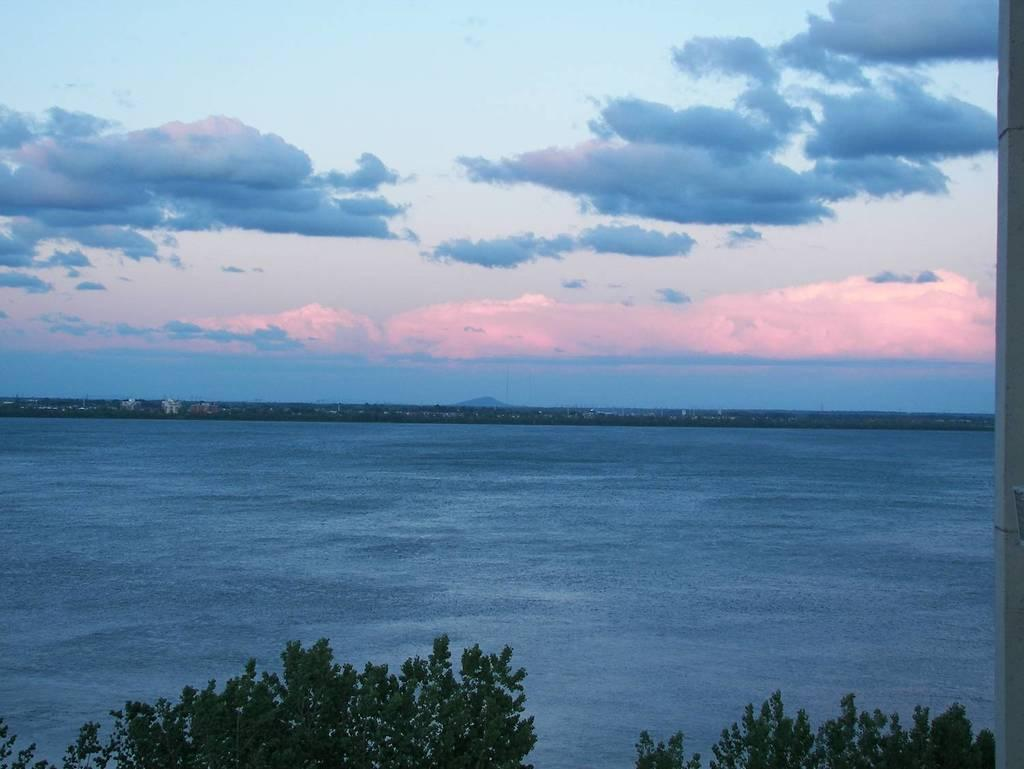What type of vegetation can be seen in the image? There are trees with branches and leaves in the image. What is happening with the water in the image? Water is flowing in the image. What can be seen in the sky in the image? Clouds are visible in the sky. What type of structures are visible in the background of the image? There are buildings in the background of the image. What type of bag can be seen hanging from the tree in the image? There is no bag hanging from the tree in the image; it only features trees with branches and leaves. What is the taste of the water flowing in the image? The taste of the water cannot be determined from the image, as taste is not a visual characteristic. 